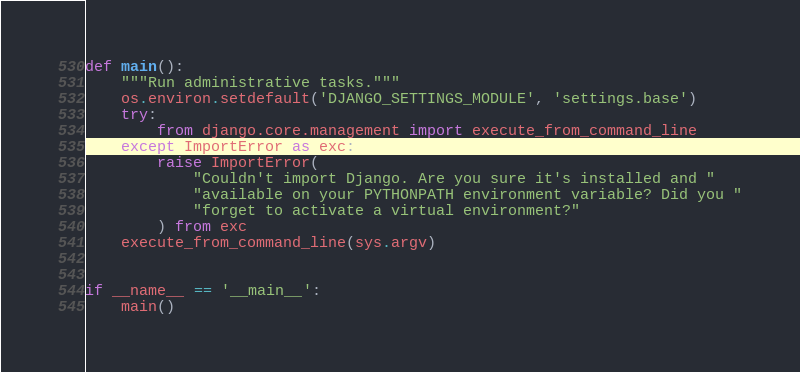Convert code to text. <code><loc_0><loc_0><loc_500><loc_500><_Python_>

def main():
    """Run administrative tasks."""
    os.environ.setdefault('DJANGO_SETTINGS_MODULE', 'settings.base')
    try:
        from django.core.management import execute_from_command_line
    except ImportError as exc:
        raise ImportError(
            "Couldn't import Django. Are you sure it's installed and "
            "available on your PYTHONPATH environment variable? Did you "
            "forget to activate a virtual environment?"
        ) from exc
    execute_from_command_line(sys.argv)


if __name__ == '__main__':
    main()
</code> 